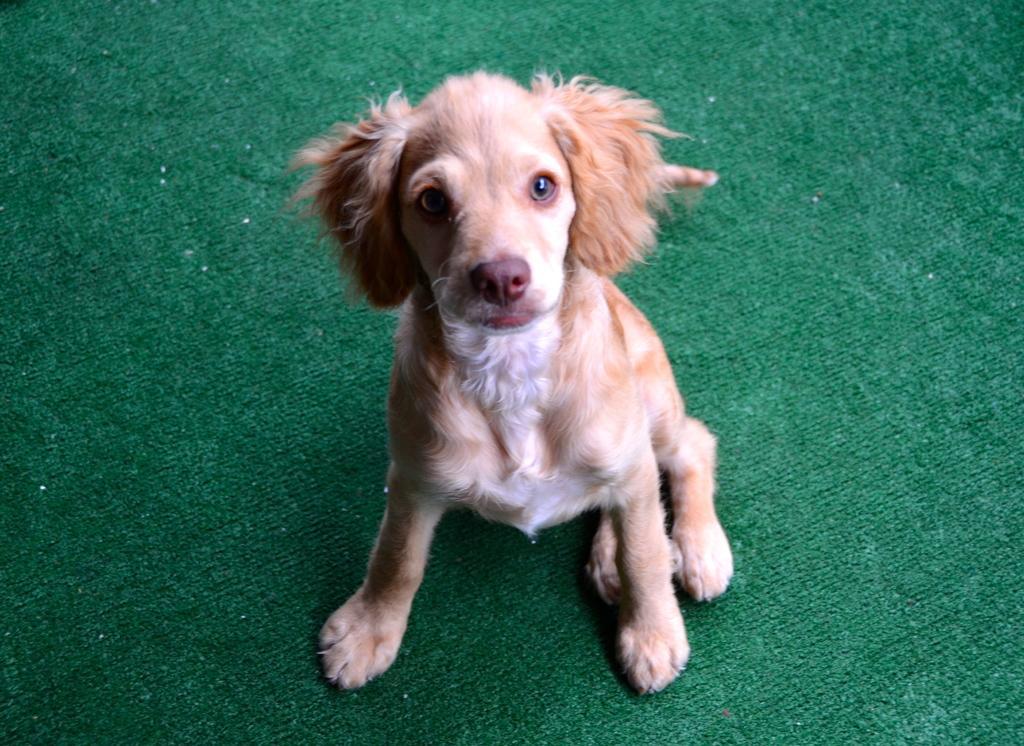In one or two sentences, can you explain what this image depicts? In this picture we can see small brown dog, sitting on the green carpet and looking to the camera. 